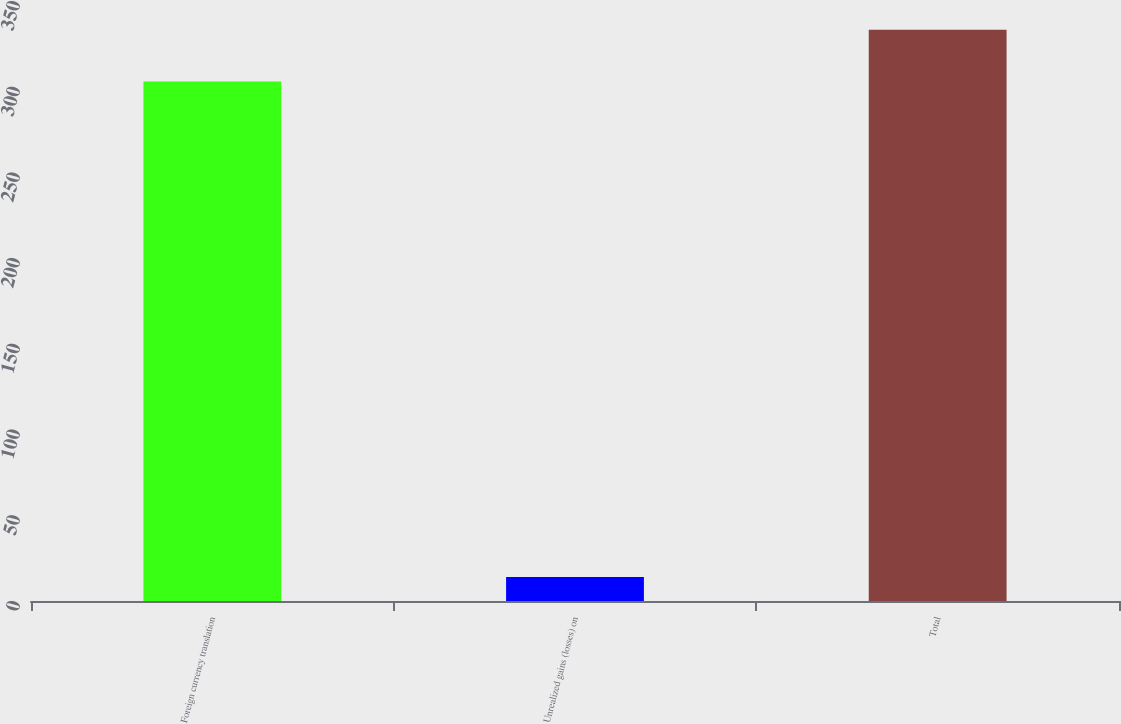Convert chart. <chart><loc_0><loc_0><loc_500><loc_500><bar_chart><fcel>Foreign currency translation<fcel>Unrealized gains (losses) on<fcel>Total<nl><fcel>303<fcel>14<fcel>333.3<nl></chart> 